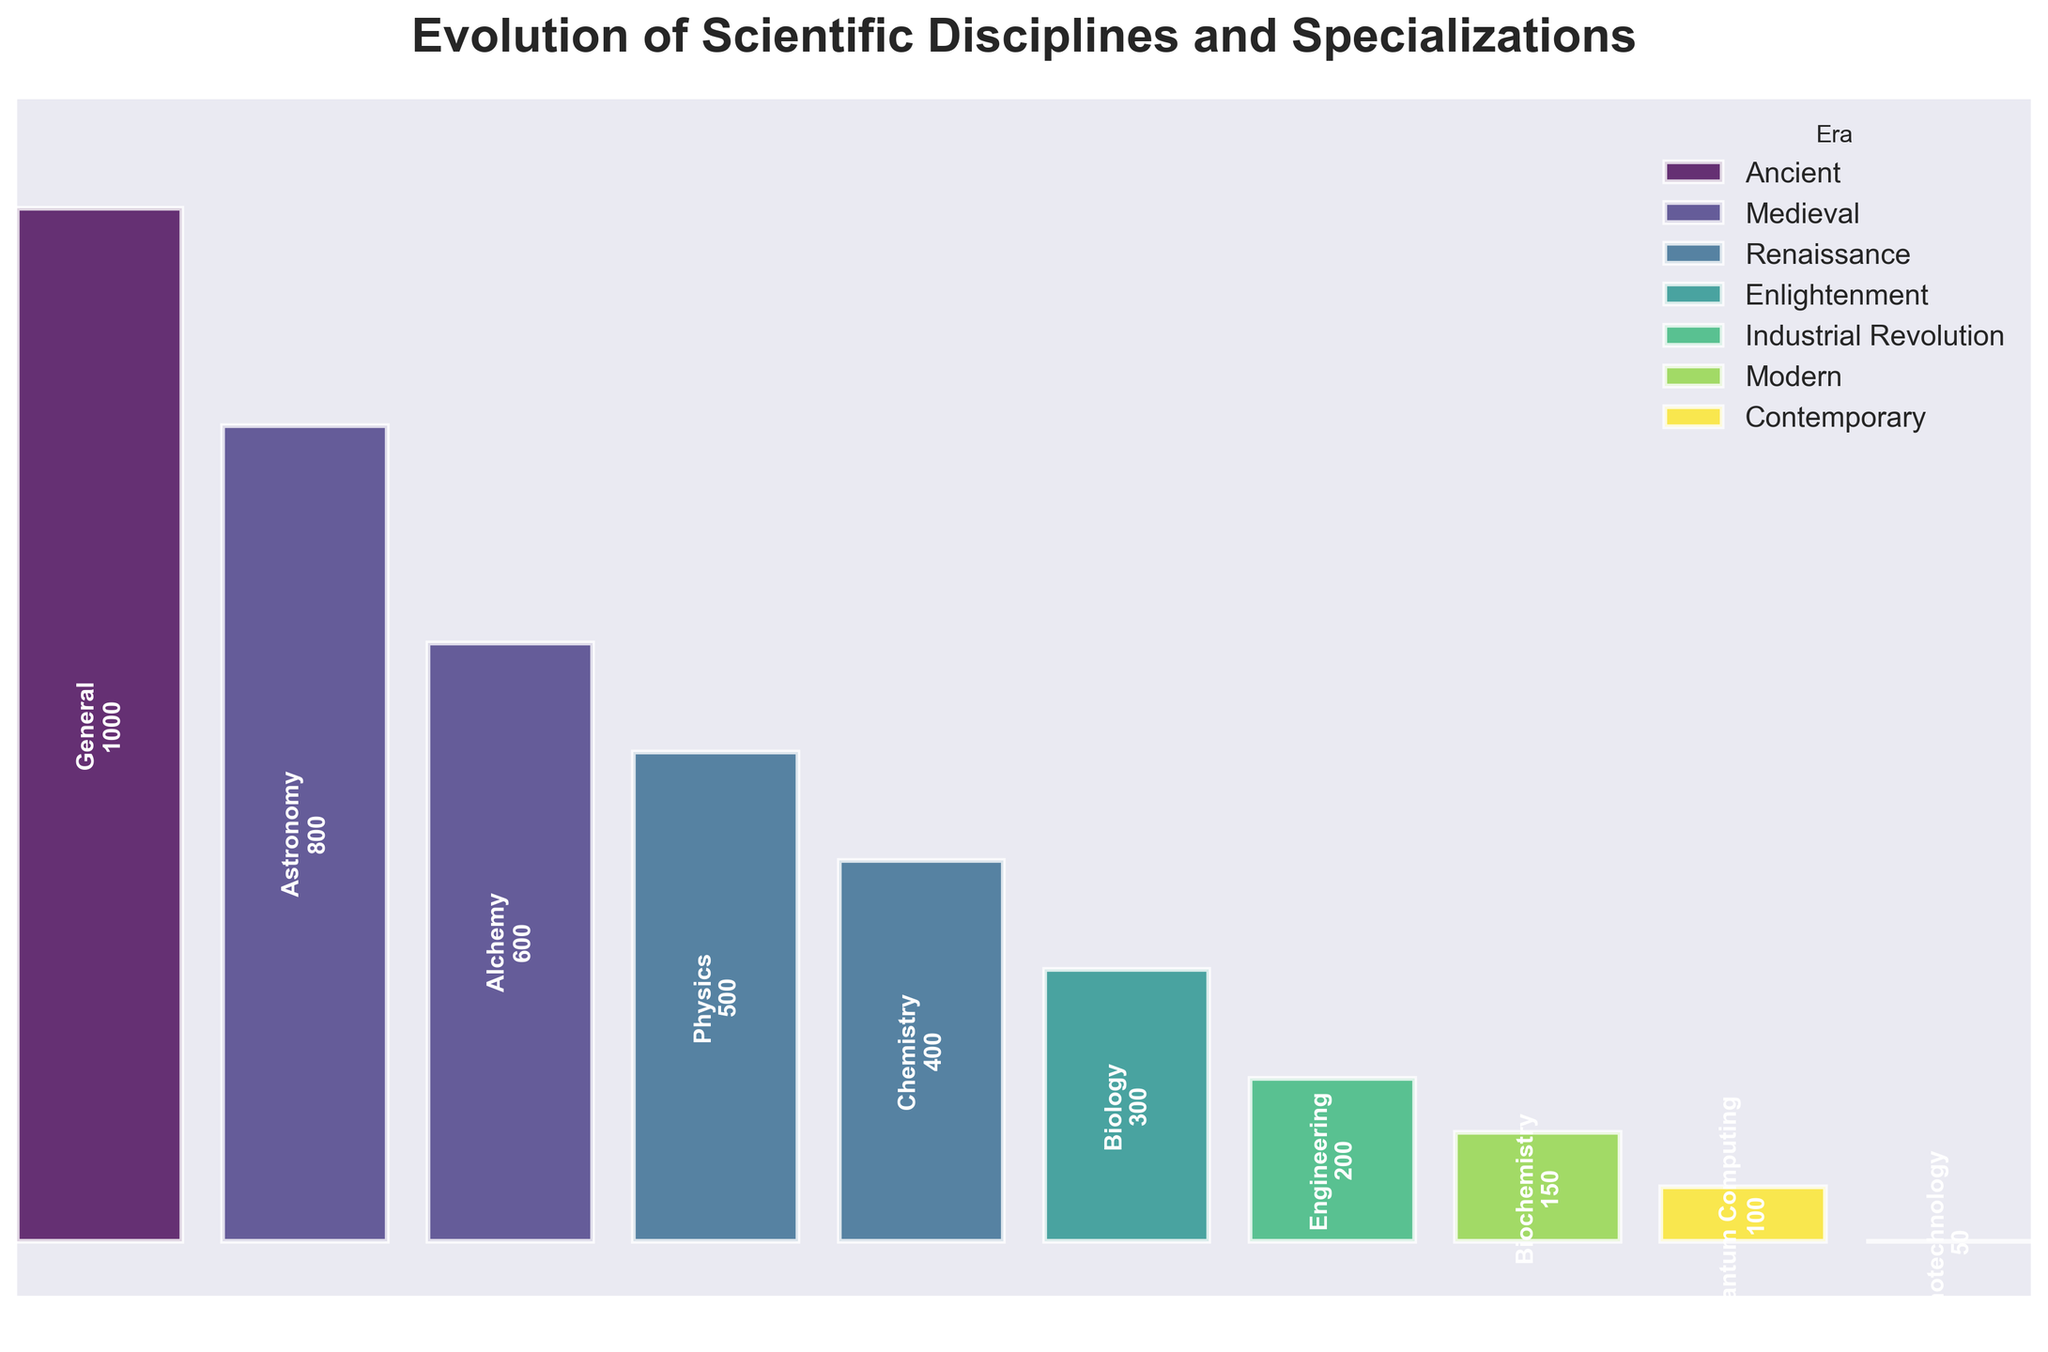What is the title of the figure? The title is often located at the top of the figure and provides a description of what the figure represents. In this case, the title reads "Evolution of Scientific Disciplines and Specializations".
Answer: Evolution of Scientific Disciplines and Specializations What era has the highest specialization count on the chart? By visually scanning through the funnel chart, the era with the highest specialization count and number of researchers is the Ancient era, marking "General" under "Natural Philosophy" with 1000 researchers.
Answer: Ancient How many researchers are there in the Modern era? Looking for the Modern era in the chart, one can see the specialization "Biochemistry" with 150 researchers in this category according to the chart.
Answer: 150 Which era follows immediately after the Medieval era in terms of specialization on the chart? The eras are listed chronologically. After the Medieval era, the Renaissance era immediately follows in the funnel chart.
Answer: Renaissance How has the number of researchers changed from the Renaissance to the Enlightenment era? The Renaissance era has 500 researchers in Physics and 400 in Chemistry. The Enlightenment era has 300 in Biology. Adding Renaissance numbers gives 900, so the decrease to Enlightenment is 900 - 300 = 600 researchers.
Answer: Decreased by 600 What specialization is represented with the fewest researchers in the chart? Scanning down to the bottom of the funnel, "Nanotechnology" in the Contemporary-specialized fields has the fewest researchers, precisely 50.
Answer: Nanotechnology What is the specialization with the highest number of researchers in the Medieval era? In the Medieval era, according to the chart, Alchemy has 600 researchers, which is greater than Astronomy's 800.
Answer: Astronomy Are there more researchers in the Industrial Revolution era or the Modern era? Checking the numbers in the chart, there are 200 researchers in the Industrial Revolution era and 150 in the Modern era. Comparing both, the Industrial Revolution has more researchers.
Answer: Industrial Revolution What is the average number of researchers for the Contemporary era specializations? The Contemporary era includes Quantum Computing with 100 researchers and Nanotechnology with 50. The average is (100 + 50) / 2 = 75 researchers.
Answer: 75 Which era shows the introduction of applied sciences? By visually inspecting the chart, the first appearance or introduction of applied sciences happens in the Industrial Revolution era with Engineering specialization.
Answer: Industrial Revolution 